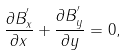<formula> <loc_0><loc_0><loc_500><loc_500>\frac { \partial B ^ { ^ { \prime } } _ { x } } { \partial x } + \frac { \partial B ^ { ^ { \prime } } _ { y } } { \partial y } = 0 ,</formula> 